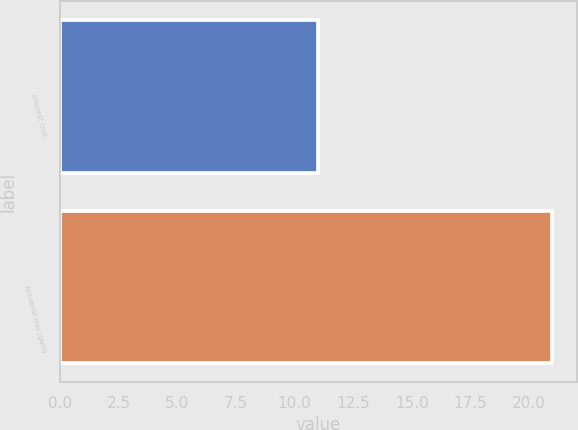<chart> <loc_0><loc_0><loc_500><loc_500><bar_chart><fcel>Interest cost<fcel>Actuarial loss (gain)<nl><fcel>11<fcel>21<nl></chart> 